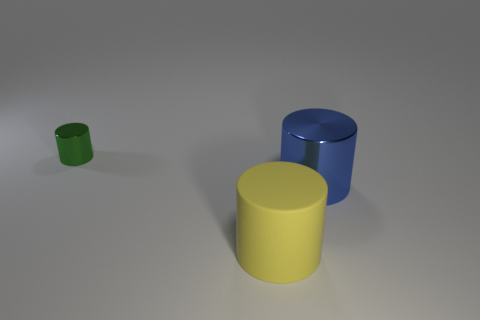Subtract all rubber cylinders. How many cylinders are left? 2 Add 2 large objects. How many objects exist? 5 Subtract all gray cylinders. Subtract all gray balls. How many cylinders are left? 3 Subtract all green metallic things. Subtract all small green cylinders. How many objects are left? 1 Add 2 large metallic objects. How many large metallic objects are left? 3 Add 3 yellow objects. How many yellow objects exist? 4 Subtract 0 purple spheres. How many objects are left? 3 